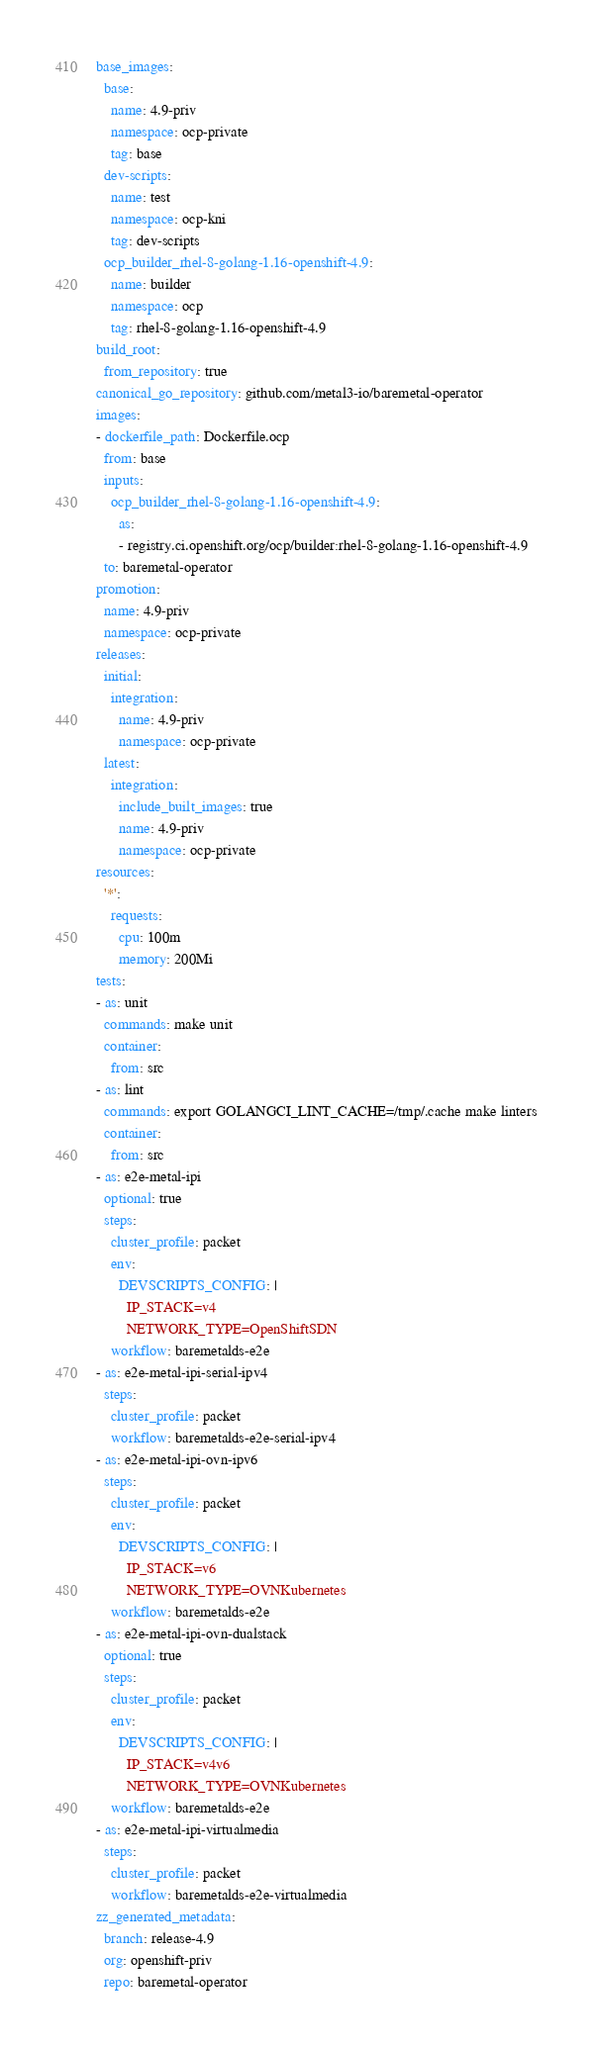<code> <loc_0><loc_0><loc_500><loc_500><_YAML_>base_images:
  base:
    name: 4.9-priv
    namespace: ocp-private
    tag: base
  dev-scripts:
    name: test
    namespace: ocp-kni
    tag: dev-scripts
  ocp_builder_rhel-8-golang-1.16-openshift-4.9:
    name: builder
    namespace: ocp
    tag: rhel-8-golang-1.16-openshift-4.9
build_root:
  from_repository: true
canonical_go_repository: github.com/metal3-io/baremetal-operator
images:
- dockerfile_path: Dockerfile.ocp
  from: base
  inputs:
    ocp_builder_rhel-8-golang-1.16-openshift-4.9:
      as:
      - registry.ci.openshift.org/ocp/builder:rhel-8-golang-1.16-openshift-4.9
  to: baremetal-operator
promotion:
  name: 4.9-priv
  namespace: ocp-private
releases:
  initial:
    integration:
      name: 4.9-priv
      namespace: ocp-private
  latest:
    integration:
      include_built_images: true
      name: 4.9-priv
      namespace: ocp-private
resources:
  '*':
    requests:
      cpu: 100m
      memory: 200Mi
tests:
- as: unit
  commands: make unit
  container:
    from: src
- as: lint
  commands: export GOLANGCI_LINT_CACHE=/tmp/.cache make linters
  container:
    from: src
- as: e2e-metal-ipi
  optional: true
  steps:
    cluster_profile: packet
    env:
      DEVSCRIPTS_CONFIG: |
        IP_STACK=v4
        NETWORK_TYPE=OpenShiftSDN
    workflow: baremetalds-e2e
- as: e2e-metal-ipi-serial-ipv4
  steps:
    cluster_profile: packet
    workflow: baremetalds-e2e-serial-ipv4
- as: e2e-metal-ipi-ovn-ipv6
  steps:
    cluster_profile: packet
    env:
      DEVSCRIPTS_CONFIG: |
        IP_STACK=v6
        NETWORK_TYPE=OVNKubernetes
    workflow: baremetalds-e2e
- as: e2e-metal-ipi-ovn-dualstack
  optional: true
  steps:
    cluster_profile: packet
    env:
      DEVSCRIPTS_CONFIG: |
        IP_STACK=v4v6
        NETWORK_TYPE=OVNKubernetes
    workflow: baremetalds-e2e
- as: e2e-metal-ipi-virtualmedia
  steps:
    cluster_profile: packet
    workflow: baremetalds-e2e-virtualmedia
zz_generated_metadata:
  branch: release-4.9
  org: openshift-priv
  repo: baremetal-operator
</code> 